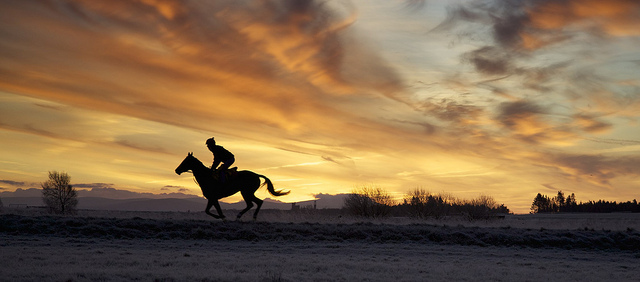What mood is evoked by the setting of the photo? The setting of the photo, with its dramatic sky and serene horizon, evokes a sense of tranquility and freedom. The silhouette of the horse and rider against the backdrop of the expansive sky can also impart a feeling of solitude and contemplation. 